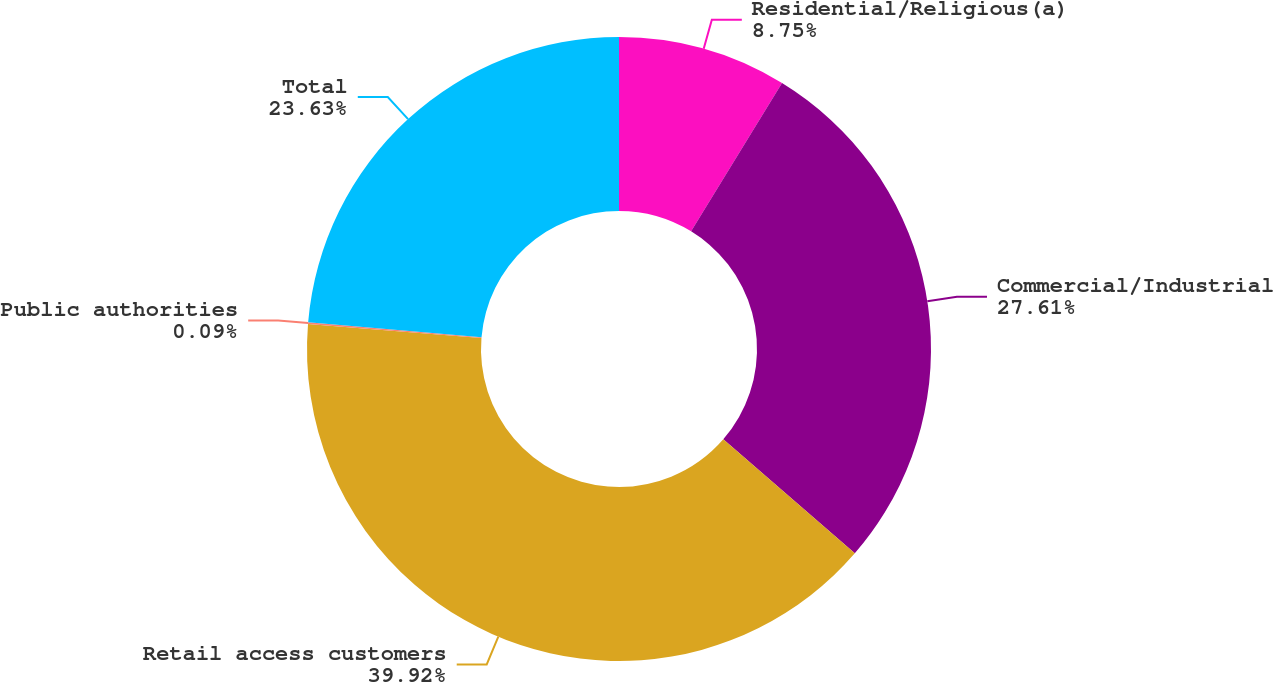Convert chart. <chart><loc_0><loc_0><loc_500><loc_500><pie_chart><fcel>Residential/Religious(a)<fcel>Commercial/Industrial<fcel>Retail access customers<fcel>Public authorities<fcel>Total<nl><fcel>8.75%<fcel>27.61%<fcel>39.91%<fcel>0.09%<fcel>23.63%<nl></chart> 